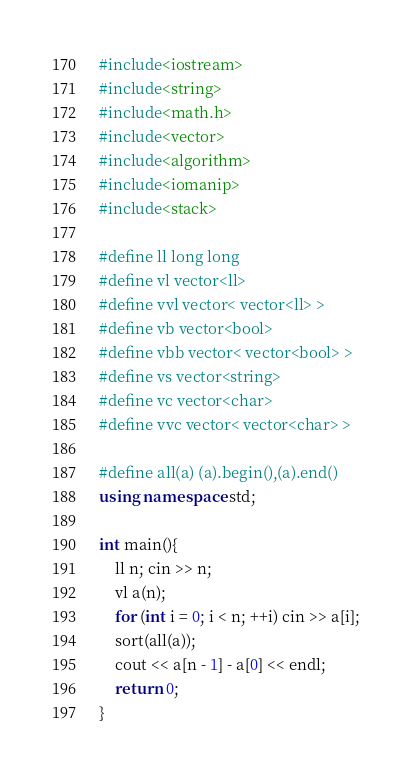<code> <loc_0><loc_0><loc_500><loc_500><_C++_>#include<iostream>
#include<string>
#include<math.h>
#include<vector>
#include<algorithm>
#include<iomanip>
#include<stack>

#define ll long long
#define vl vector<ll>
#define vvl vector< vector<ll> >
#define vb vector<bool>
#define vbb vector< vector<bool> >
#define vs vector<string>
#define vc vector<char>
#define vvc vector< vector<char> >

#define all(a) (a).begin(),(a).end()
using namespace std;

int main(){
	ll n; cin >> n;
	vl a(n);
	for (int i = 0; i < n; ++i) cin >> a[i];
	sort(all(a));
	cout << a[n - 1] - a[0] << endl;
	return 0;
}</code> 